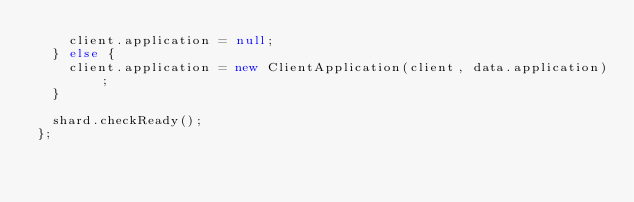<code> <loc_0><loc_0><loc_500><loc_500><_JavaScript_>    client.application = null;
  } else {
    client.application = new ClientApplication(client, data.application);
  }

  shard.checkReady();
};
</code> 